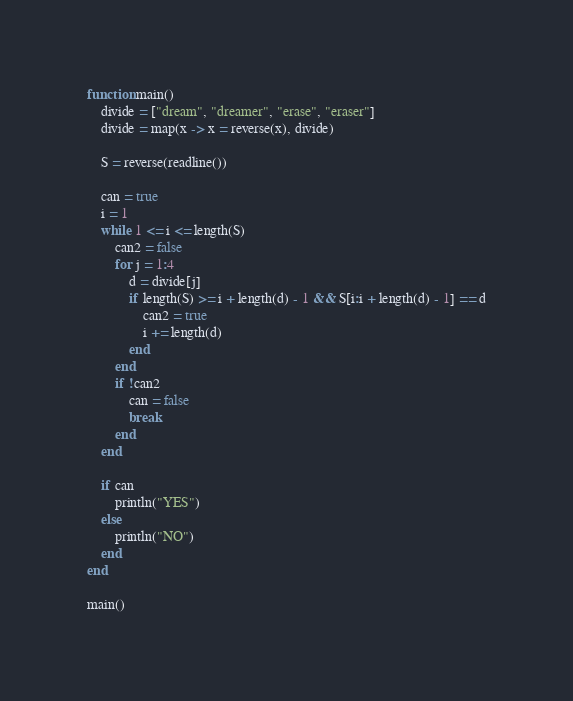Convert code to text. <code><loc_0><loc_0><loc_500><loc_500><_Julia_>function main()
    divide = ["dream", "dreamer", "erase", "eraser"]
    divide = map(x -> x = reverse(x), divide)

    S = reverse(readline())

    can = true
    i = 1
    while 1 <= i <= length(S)
        can2 = false
        for j = 1:4
            d = divide[j]
            if length(S) >= i + length(d) - 1 && S[i:i + length(d) - 1] == d
                can2 = true
                i += length(d)
            end
        end
        if !can2
            can = false
            break
        end
    end

    if can
        println("YES")
    else
        println("NO")
    end
end

main()</code> 